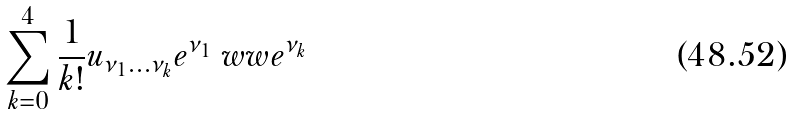Convert formula to latex. <formula><loc_0><loc_0><loc_500><loc_500>\sum ^ { 4 } _ { k = 0 } \frac { 1 } { k ! } u _ { \nu _ { 1 } \dots \nu _ { k } } e ^ { \nu _ { 1 } } \ w w e ^ { \nu _ { k } }</formula> 